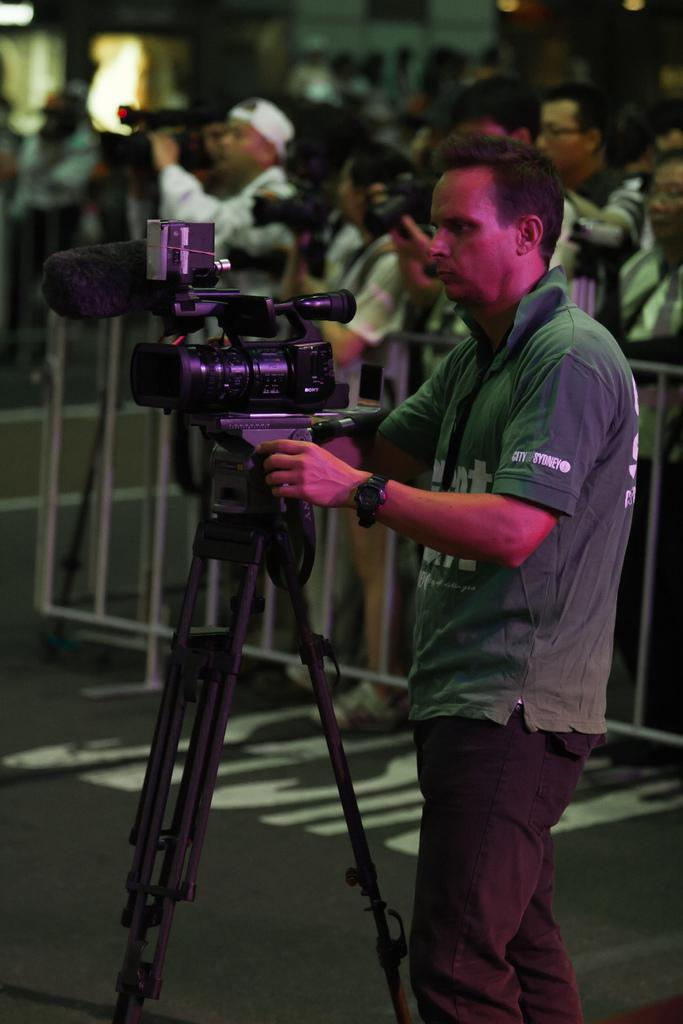What is the man in the image doing? The man is standing on the road and holding a camera with his hands. What can be seen in the background of the image? There is a group of people standing at a fence in the background of the image. What might the man be planning to do with the camera? The man might be planning to take a picture or record something with the camera. How many sheep are visible in the image? There are no sheep present in the image. What type of crime is being committed in the image? There is no crime being committed in the image; it features a man holding a camera and a group of people standing at a fence. 